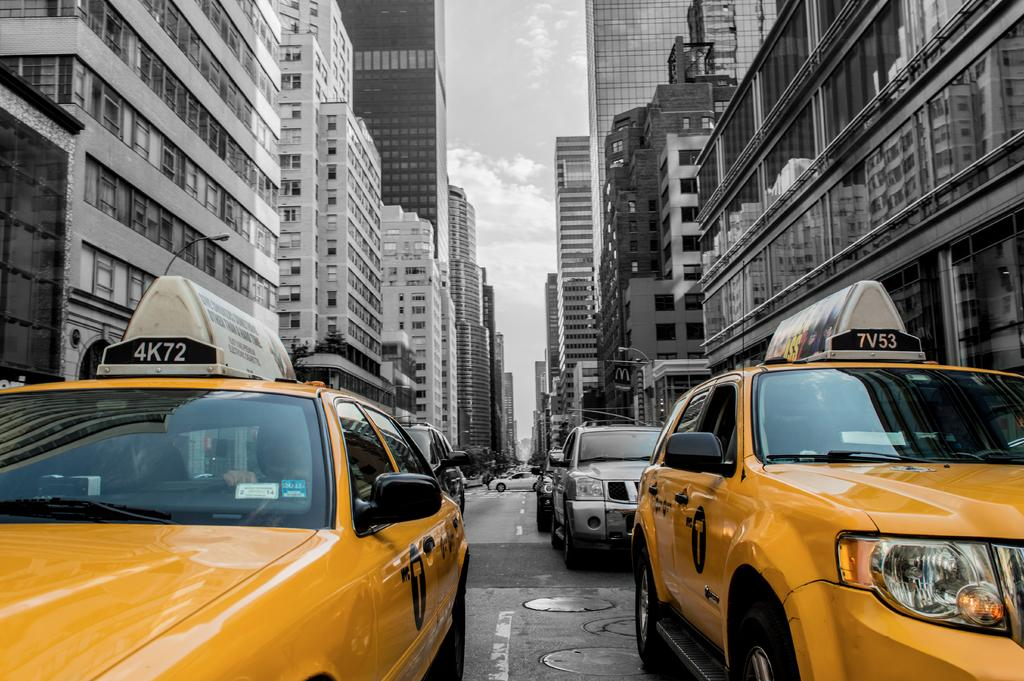<image>
Relay a brief, clear account of the picture shown. A New York City taxi has TV53 on the top of it 